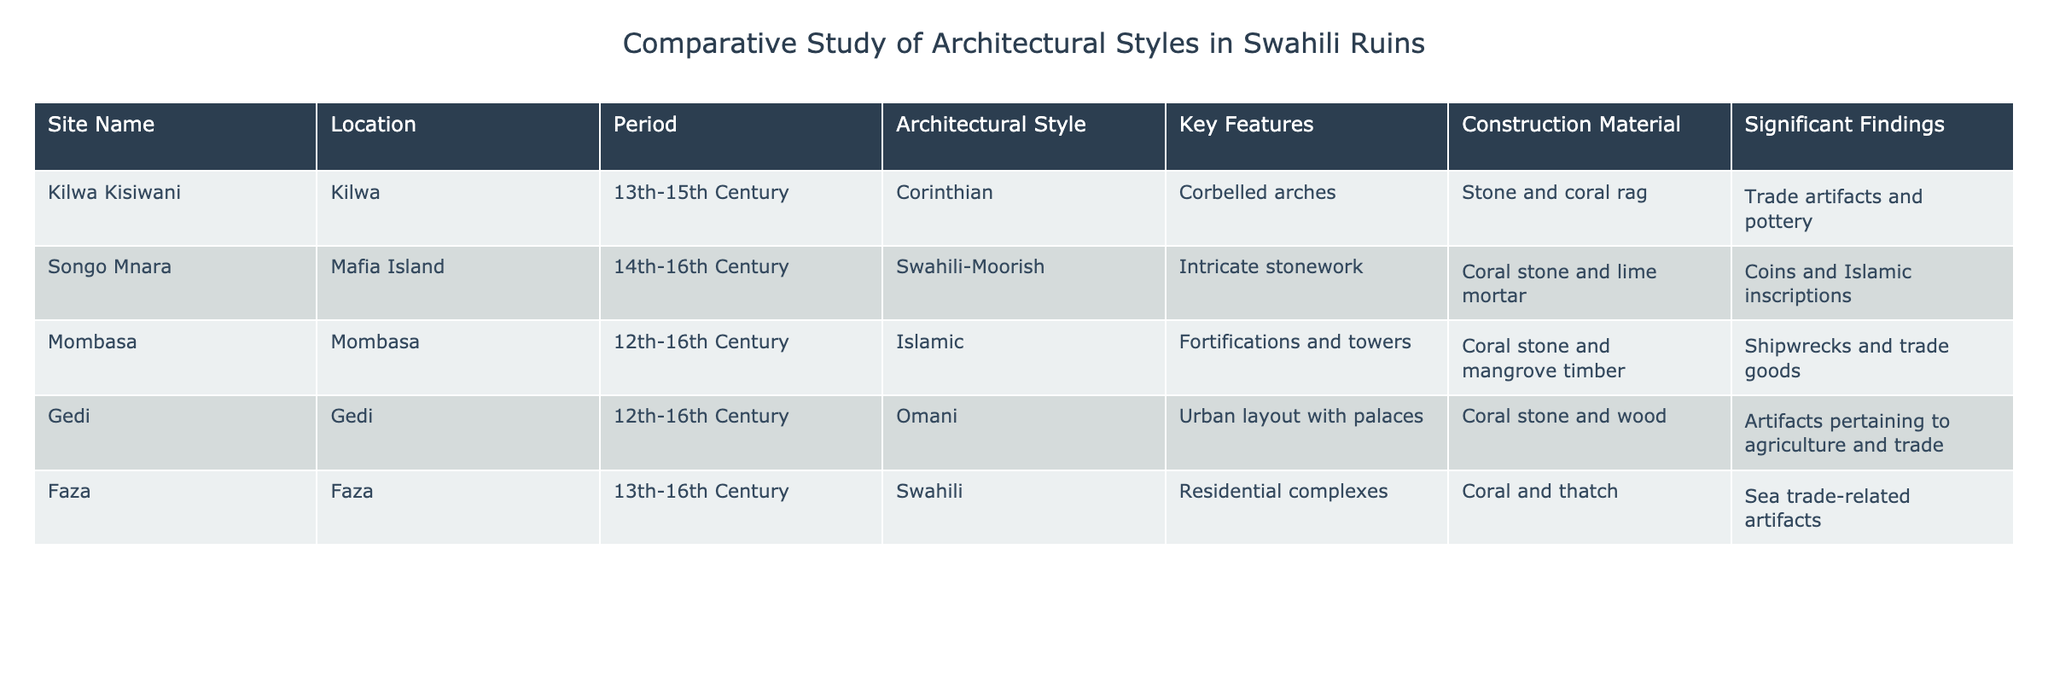What is the construction material used for the site Mombasa? The construction material listed for Mombasa is "Coral stone and mangrove timber," which is mentioned directly in the table under the Construction Material column for that site.
Answer: Coral stone and mangrove timber Which site has the most significant findings related to trade artifacts? The site Kilwa Kisiwani has significant findings listed as "Trade artifacts and pottery." Looking at the significant findings column, no other site lists trade artifacts specifically except for Kilwa Kisiwani.
Answer: Kilwa Kisiwani Is the architectural style used in Faza classified as Swahili? The architectural style for Faza is "Swahili," which can be found in the Architectural Style column of the table. Therefore, the statement is true based on the provided data.
Answer: Yes What period did the site Songo Mnara belong to and what type of architectural style is it associated with? According to the table, Songo Mnara belongs to the period "14th-16th Century" and has the architectural style of "Swahili-Moorish." This information is found in the corresponding columns under Songo Mnara.
Answer: 14th-16th Century, Swahili-Moorish How many different architectural styles are represented in the table? The architectural styles listed are Corinthian, Swahili-Moorish, Islamic, Omani, and Swahili. Counting these, there are five different architectural styles represented in the table, which can be confirmed by examining the Architectural Style column and listing the unique entries.
Answer: Five What is the average number of centuries represented in the periods for these sites? The periods are 13th-15th Century, 14th-16th Century, 12th-16th Century, 12th-16th Century, and 13th-16th Century. With midpoint values of 14th, 15th, 14th, 14th, and 15th century, the average is (14+15+14+14+15)/5 = 14.4. Thus, the average number of centuries is 14.4, calculated by summing the middle values and dividing by the number of data points.
Answer: 14.4 Does Gedi have architectural features related to urban layout with palaces? Yes, according to the table, Gedi is associated with the architectural feature described as "Urban layout with palaces." This is derived directly from the Key Features column.
Answer: Yes 